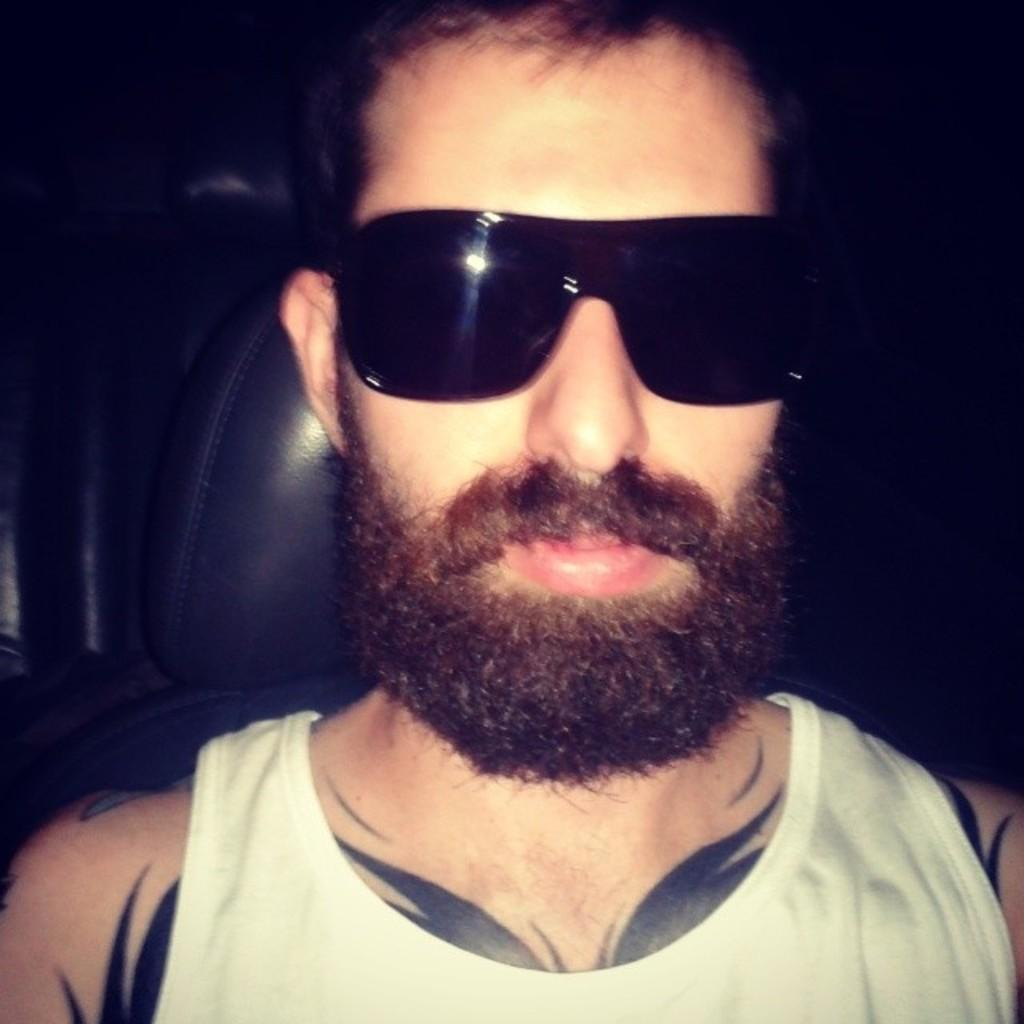Who is present in the image? There is a person in the image. What is the person doing in the image? The person is sitting on a seat. What protective gear is the person wearing? The person is wearing goggles. Can you describe the person's facial hair? The person has a beard. What type of body art can be seen on the person? The person has tattoos on their body. What type of owl can be seen perched on the person's shoulder in the image? There is no owl present in the image; the person is not accompanied by any animal. 